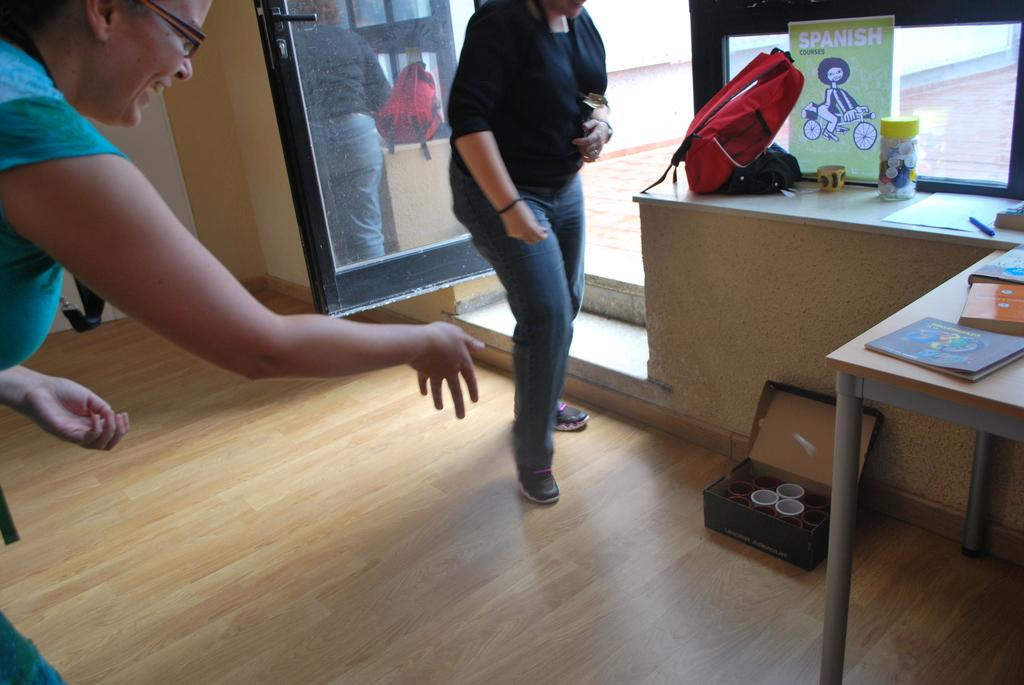How many people are present in the image? There are two persons standing in the image. What surface are the persons standing on? The persons are standing on the floor. What objects can be seen on a piece of furniture in the image? There are books on a table in the image. Where is the bag located in the image? The bag is on a shelf in the image. What type of slope can be seen in the image? There is no slope present in the image. What pen is the person using to write in the image? There is no pen or writing activity depicted in the image. 